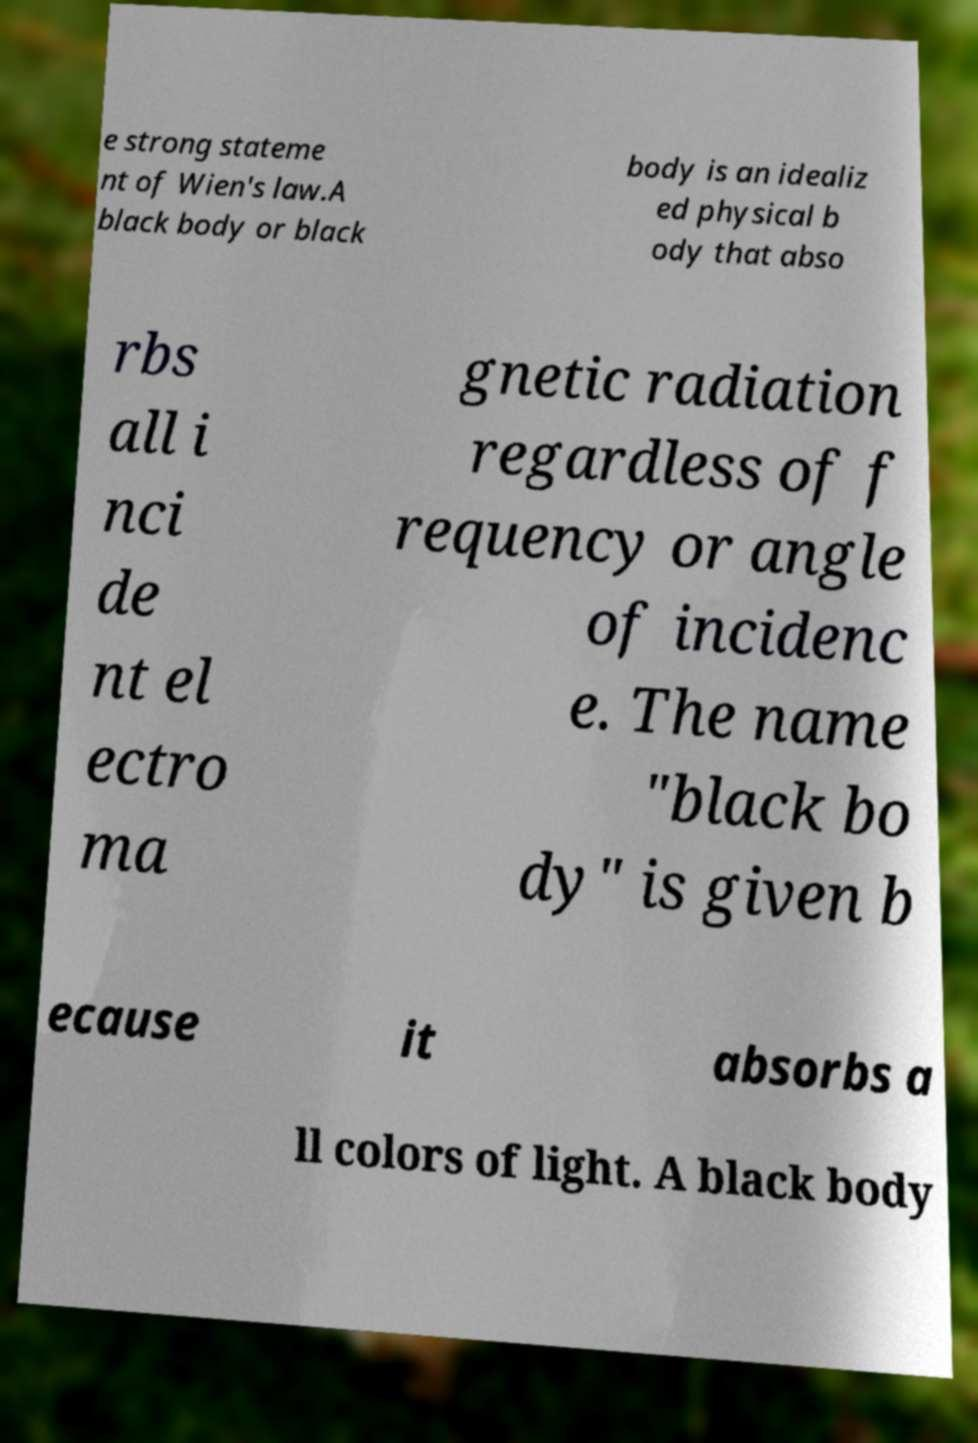Can you read and provide the text displayed in the image?This photo seems to have some interesting text. Can you extract and type it out for me? e strong stateme nt of Wien's law.A black body or black body is an idealiz ed physical b ody that abso rbs all i nci de nt el ectro ma gnetic radiation regardless of f requency or angle of incidenc e. The name "black bo dy" is given b ecause it absorbs a ll colors of light. A black body 